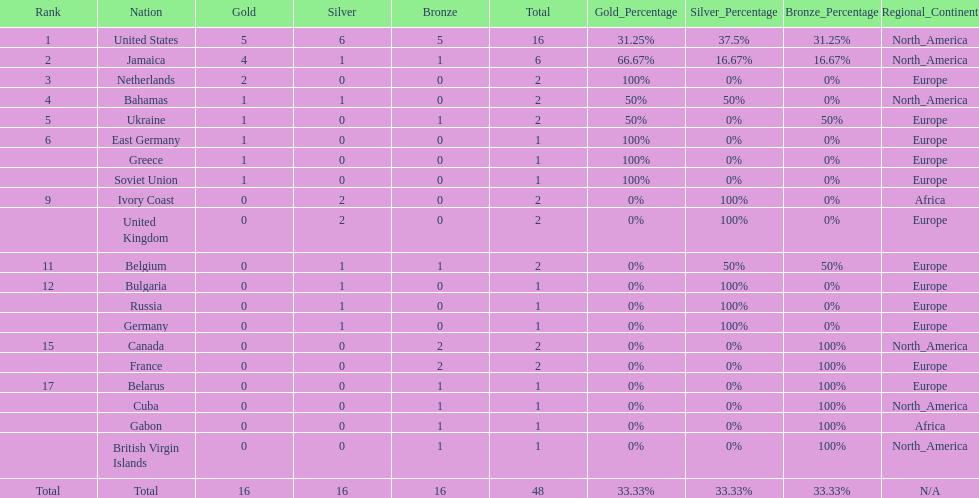How many nations received more medals than canada? 2. 